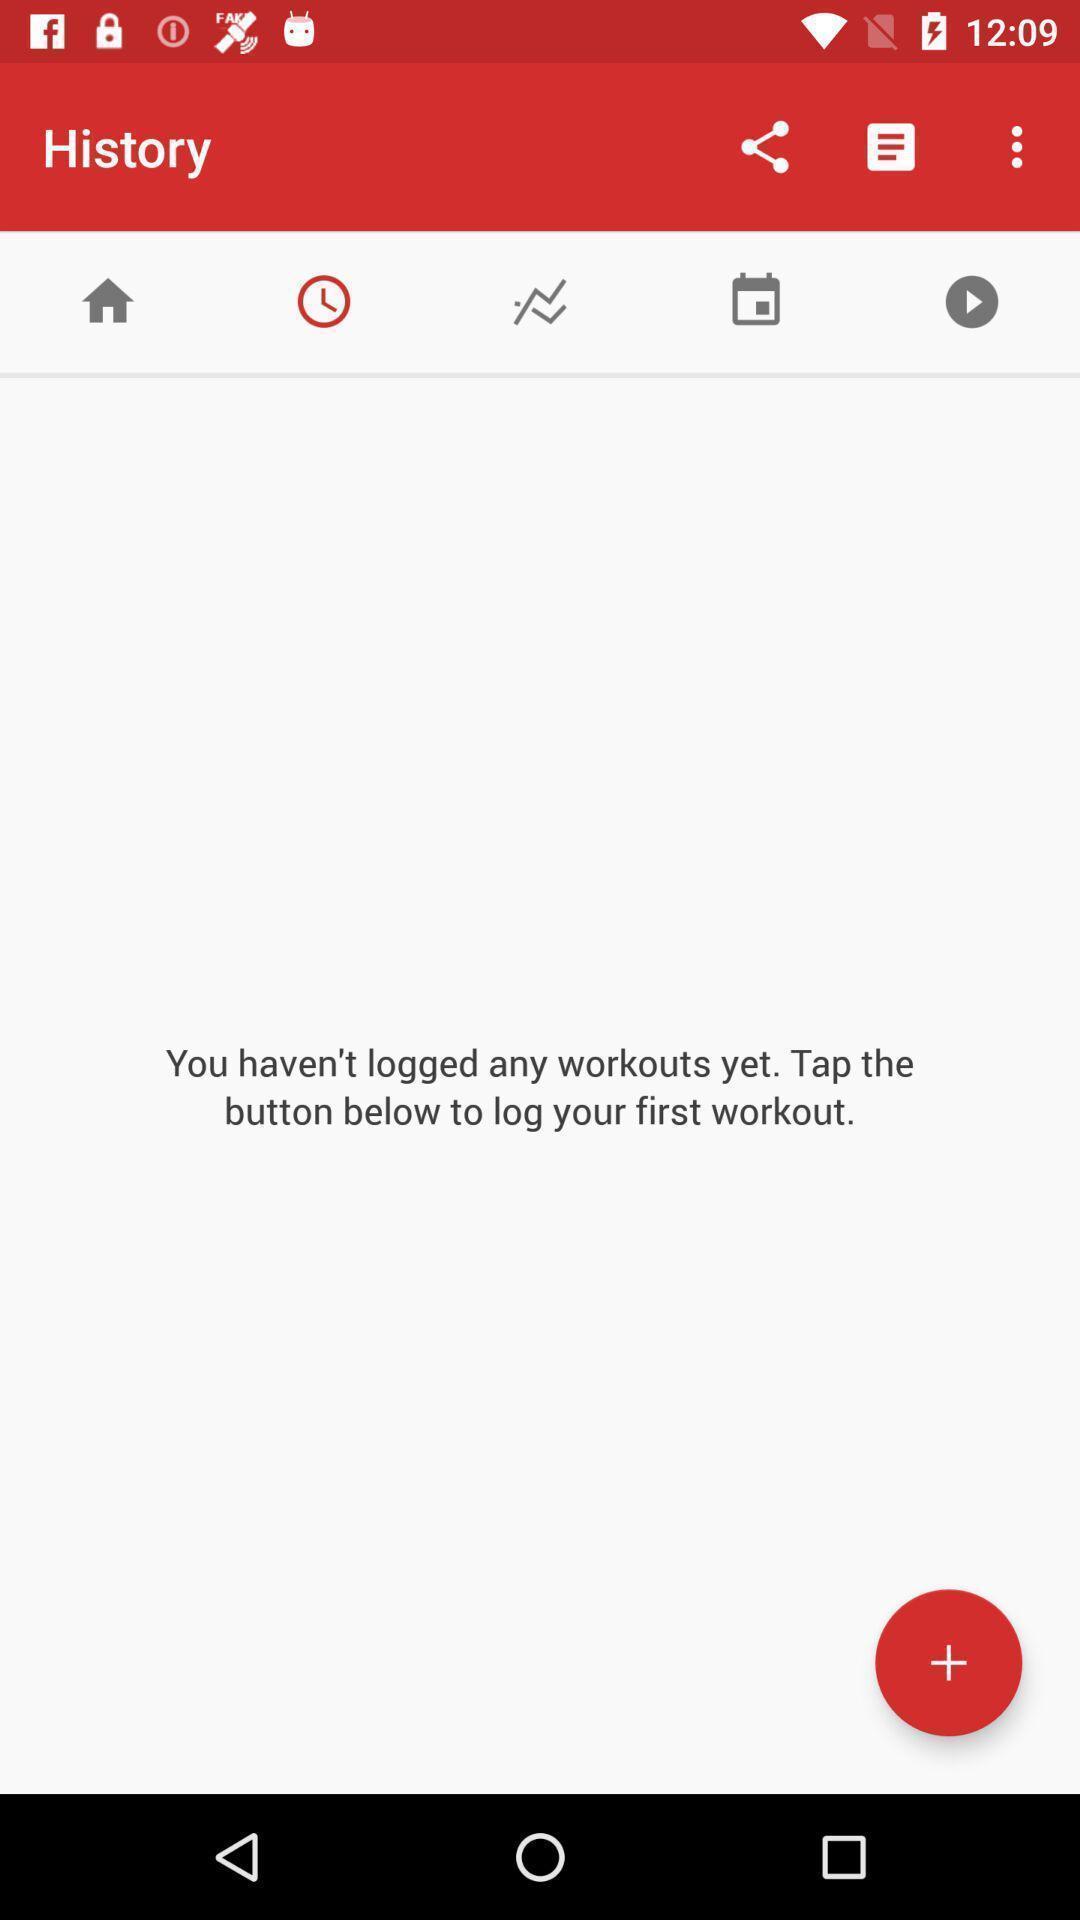Explain the elements present in this screenshot. Screen shows history details of a fitness application. 